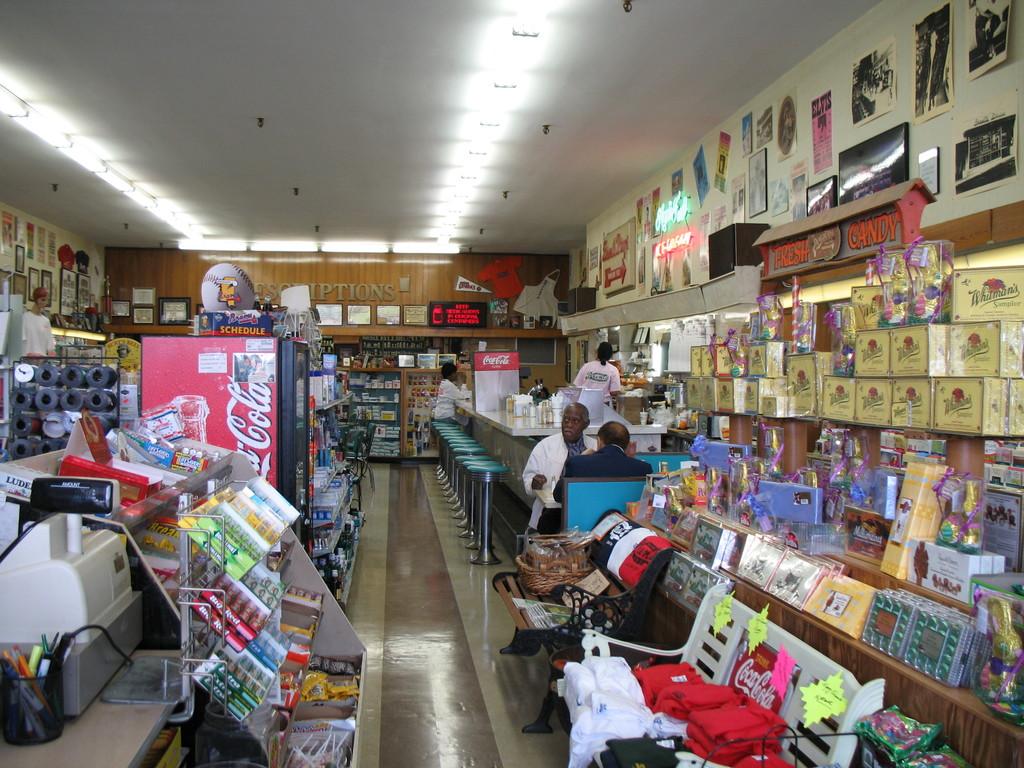What brand is represented on the fridge?
Provide a short and direct response. Coca cola. 